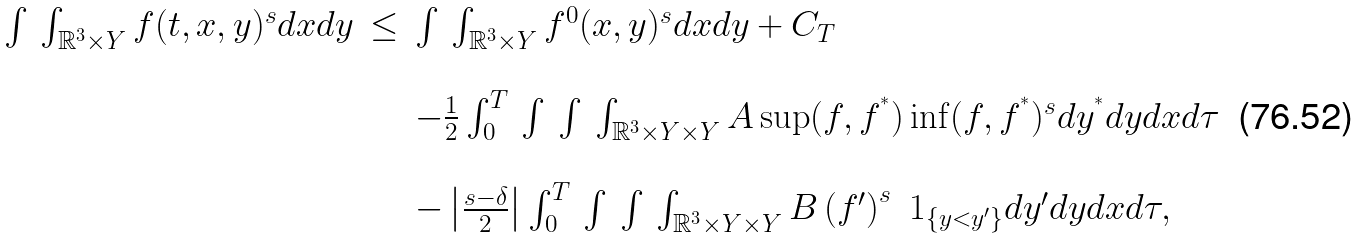<formula> <loc_0><loc_0><loc_500><loc_500>\begin{array} { l l l } \int \, \int _ { \mathbb { R } ^ { 3 } \times Y } f ( t , x , y ) ^ { s } d x d y & \leq & \int \, \int _ { \mathbb { R } ^ { 3 } \times Y } f ^ { 0 } ( x , y ) ^ { s } d x d y + C _ { T } \\ \\ & & - \frac { 1 } { 2 } \int _ { 0 } ^ { T } \, \int \, \int \, \int _ { \mathbb { R } ^ { 3 } \times Y \times Y } A \sup ( f , f ^ { ^ { * } } ) \inf ( f , f ^ { ^ { * } } ) ^ { s } d y ^ { ^ { * } } d y d x d \tau \\ \\ & & - \left | \frac { s - \delta } { 2 } \right | \int _ { 0 } ^ { T } \, \int \, \int \, \int _ { \mathbb { R } ^ { 3 } \times Y \times Y } B \left ( f ^ { \prime } \right ) ^ { s } \ 1 _ { \{ y < y ^ { \prime } \} } d y ^ { \prime } d y d x d \tau , \end{array}</formula> 